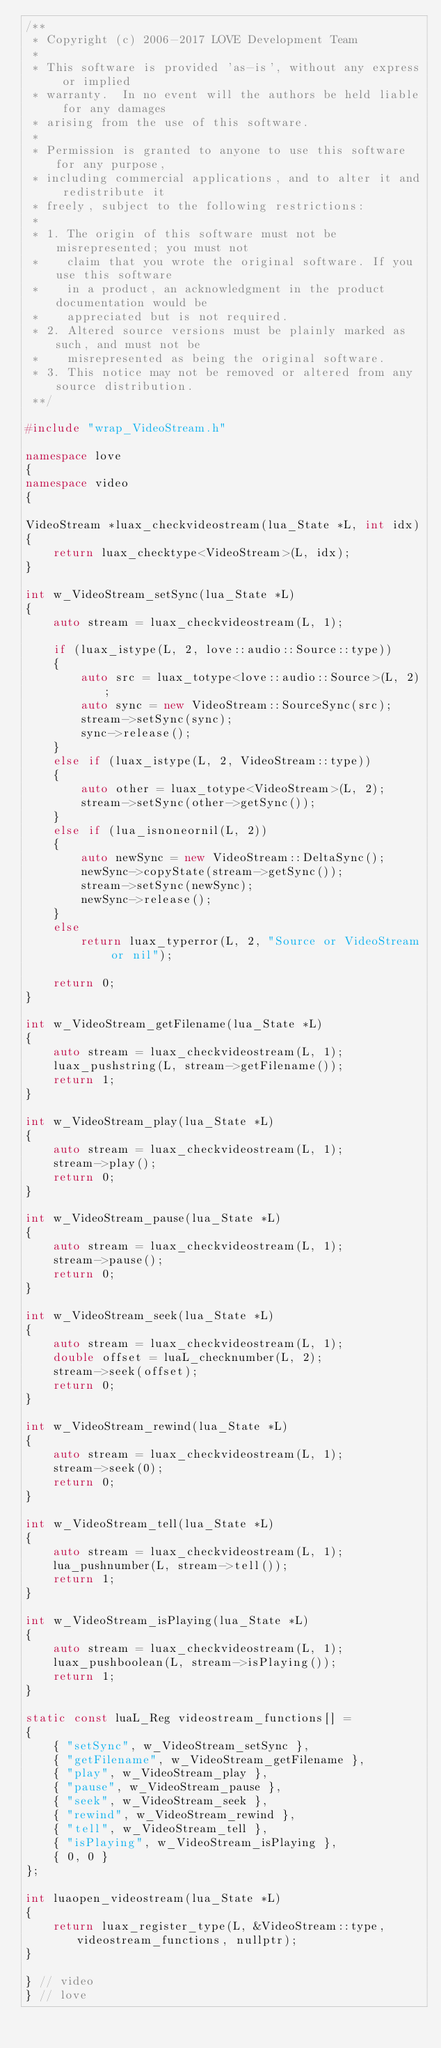Convert code to text. <code><loc_0><loc_0><loc_500><loc_500><_C++_>/**
 * Copyright (c) 2006-2017 LOVE Development Team
 *
 * This software is provided 'as-is', without any express or implied
 * warranty.  In no event will the authors be held liable for any damages
 * arising from the use of this software.
 *
 * Permission is granted to anyone to use this software for any purpose,
 * including commercial applications, and to alter it and redistribute it
 * freely, subject to the following restrictions:
 *
 * 1. The origin of this software must not be misrepresented; you must not
 *    claim that you wrote the original software. If you use this software
 *    in a product, an acknowledgment in the product documentation would be
 *    appreciated but is not required.
 * 2. Altered source versions must be plainly marked as such, and must not be
 *    misrepresented as being the original software.
 * 3. This notice may not be removed or altered from any source distribution.
 **/

#include "wrap_VideoStream.h"

namespace love
{
namespace video
{

VideoStream *luax_checkvideostream(lua_State *L, int idx)
{
	return luax_checktype<VideoStream>(L, idx);
}

int w_VideoStream_setSync(lua_State *L)
{
	auto stream = luax_checkvideostream(L, 1);

	if (luax_istype(L, 2, love::audio::Source::type))
	{
		auto src = luax_totype<love::audio::Source>(L, 2);
		auto sync = new VideoStream::SourceSync(src);
		stream->setSync(sync);
		sync->release();
	}
	else if (luax_istype(L, 2, VideoStream::type))
	{
		auto other = luax_totype<VideoStream>(L, 2);
		stream->setSync(other->getSync());
	}
	else if (lua_isnoneornil(L, 2))
	{
		auto newSync = new VideoStream::DeltaSync();
		newSync->copyState(stream->getSync());
		stream->setSync(newSync);
		newSync->release();
	}
	else
		return luax_typerror(L, 2, "Source or VideoStream or nil");

	return 0;
}

int w_VideoStream_getFilename(lua_State *L)
{
	auto stream = luax_checkvideostream(L, 1);
	luax_pushstring(L, stream->getFilename());
	return 1;
}

int w_VideoStream_play(lua_State *L)
{
	auto stream = luax_checkvideostream(L, 1);
	stream->play();
	return 0;
}

int w_VideoStream_pause(lua_State *L)
{
	auto stream = luax_checkvideostream(L, 1);
	stream->pause();
	return 0;
}

int w_VideoStream_seek(lua_State *L)
{
	auto stream = luax_checkvideostream(L, 1);
	double offset = luaL_checknumber(L, 2);
	stream->seek(offset);
	return 0;
}

int w_VideoStream_rewind(lua_State *L)
{
	auto stream = luax_checkvideostream(L, 1);
	stream->seek(0);
	return 0;
}

int w_VideoStream_tell(lua_State *L)
{
	auto stream = luax_checkvideostream(L, 1);
	lua_pushnumber(L, stream->tell());
	return 1;
}

int w_VideoStream_isPlaying(lua_State *L)
{
	auto stream = luax_checkvideostream(L, 1);
	luax_pushboolean(L, stream->isPlaying());
	return 1;
}

static const luaL_Reg videostream_functions[] =
{
	{ "setSync", w_VideoStream_setSync },
	{ "getFilename", w_VideoStream_getFilename },
	{ "play", w_VideoStream_play },
	{ "pause", w_VideoStream_pause },
	{ "seek", w_VideoStream_seek },
	{ "rewind", w_VideoStream_rewind },
	{ "tell", w_VideoStream_tell },
	{ "isPlaying", w_VideoStream_isPlaying },
	{ 0, 0 }
};

int luaopen_videostream(lua_State *L)
{
	return luax_register_type(L, &VideoStream::type, videostream_functions, nullptr);
}

} // video
} // love
</code> 